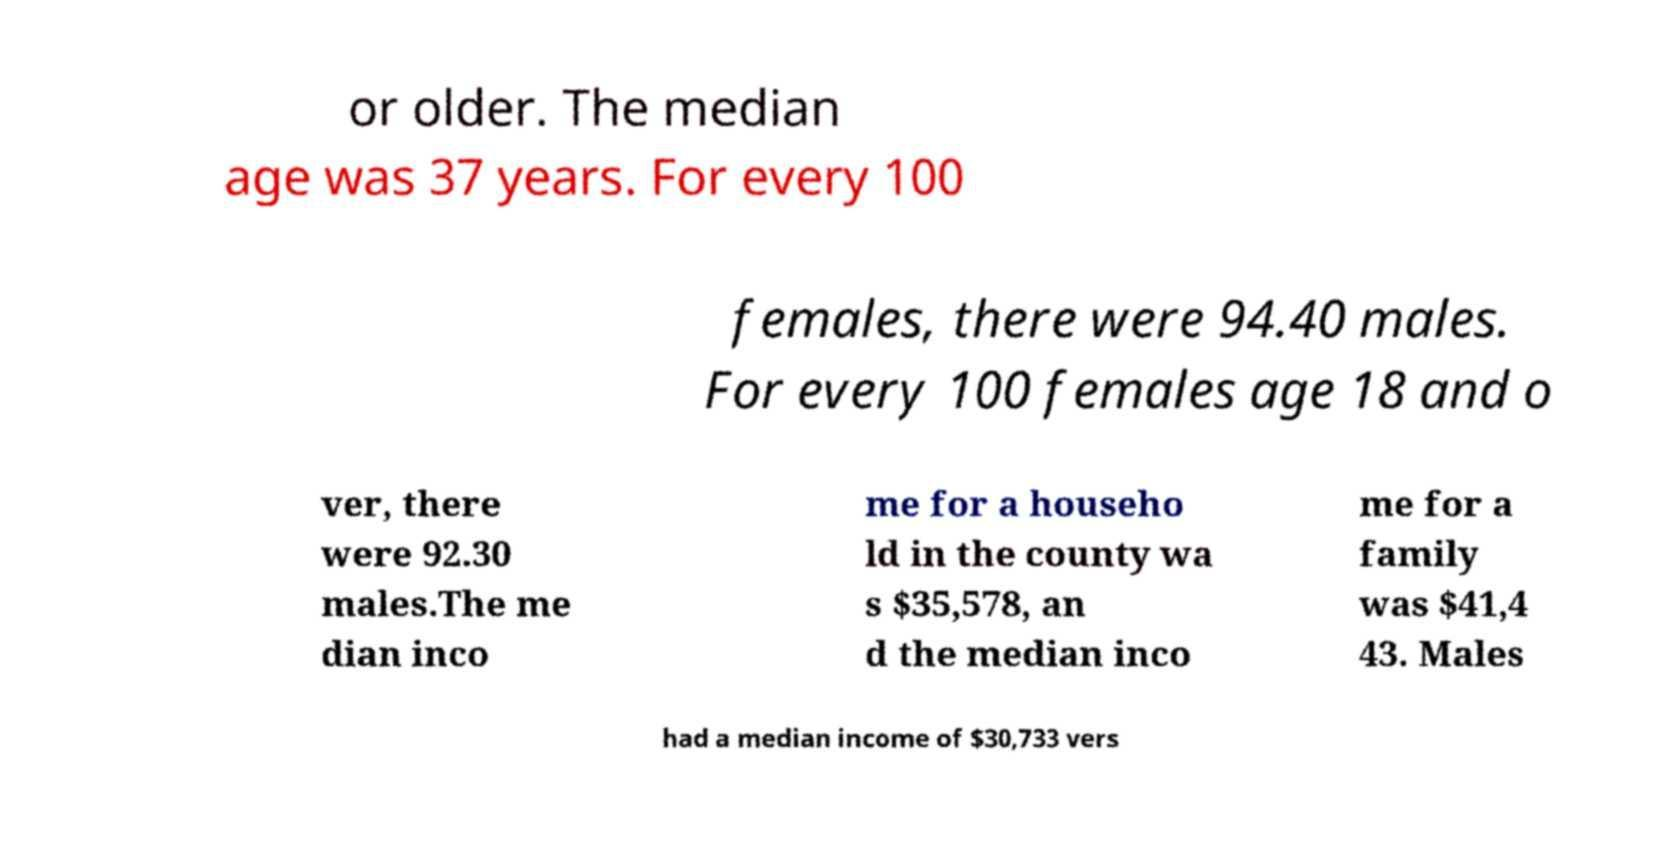Please identify and transcribe the text found in this image. or older. The median age was 37 years. For every 100 females, there were 94.40 males. For every 100 females age 18 and o ver, there were 92.30 males.The me dian inco me for a househo ld in the county wa s $35,578, an d the median inco me for a family was $41,4 43. Males had a median income of $30,733 vers 